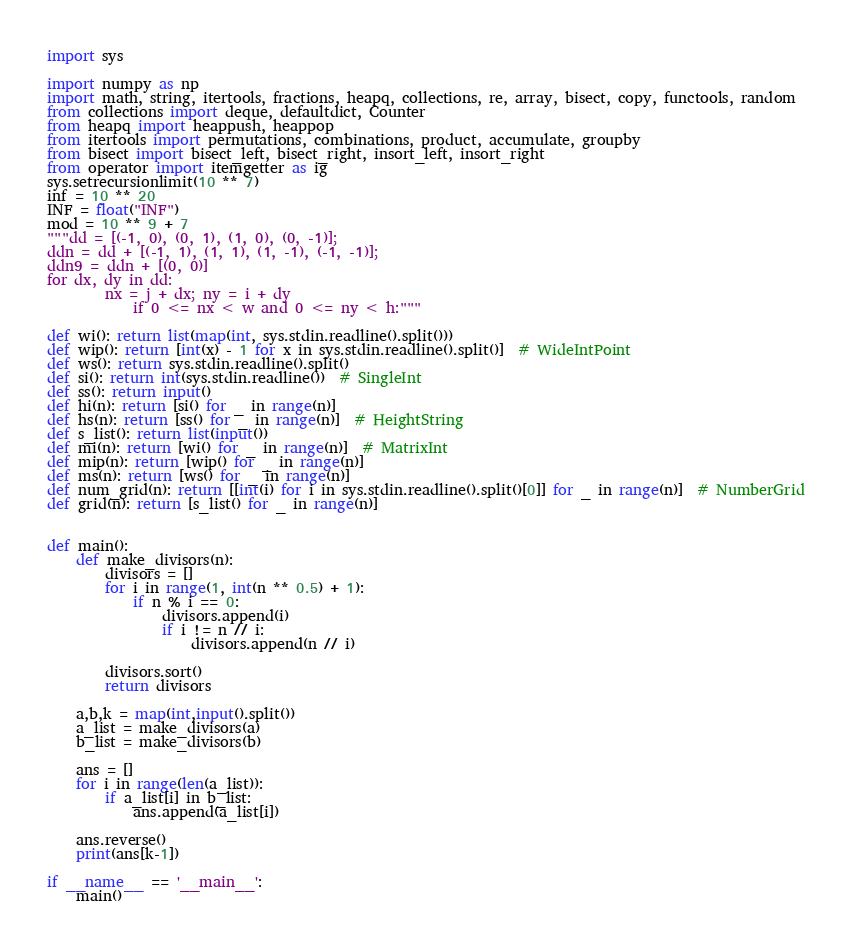<code> <loc_0><loc_0><loc_500><loc_500><_Python_>import sys

import numpy as np
import math, string, itertools, fractions, heapq, collections, re, array, bisect, copy, functools, random
from collections import deque, defaultdict, Counter
from heapq import heappush, heappop
from itertools import permutations, combinations, product, accumulate, groupby
from bisect import bisect_left, bisect_right, insort_left, insort_right
from operator import itemgetter as ig
sys.setrecursionlimit(10 ** 7)
inf = 10 ** 20
INF = float("INF")
mod = 10 ** 9 + 7
"""dd = [(-1, 0), (0, 1), (1, 0), (0, -1)];
ddn = dd + [(-1, 1), (1, 1), (1, -1), (-1, -1)];
ddn9 = ddn + [(0, 0)]
for dx, dy in dd:
        nx = j + dx; ny = i + dy
            if 0 <= nx < w and 0 <= ny < h:"""

def wi(): return list(map(int, sys.stdin.readline().split()))
def wip(): return [int(x) - 1 for x in sys.stdin.readline().split()]  # WideIntPoint
def ws(): return sys.stdin.readline().split()
def si(): return int(sys.stdin.readline())  # SingleInt
def ss(): return input()
def hi(n): return [si() for _ in range(n)]
def hs(n): return [ss() for _ in range(n)]  # HeightString
def s_list(): return list(input())
def mi(n): return [wi() for _ in range(n)]  # MatrixInt
def mip(n): return [wip() for _ in range(n)]
def ms(n): return [ws() for _ in range(n)]
def num_grid(n): return [[int(i) for i in sys.stdin.readline().split()[0]] for _ in range(n)]  # NumberGrid
def grid(n): return [s_list() for _ in range(n)]


def main():
    def make_divisors(n):
        divisors = []
        for i in range(1, int(n ** 0.5) + 1):
            if n % i == 0:
                divisors.append(i)
                if i != n // i:
                    divisors.append(n // i)

        divisors.sort()
        return divisors

    a,b,k = map(int,input().split())
    a_list = make_divisors(a)
    b_list = make_divisors(b)

    ans = []
    for i in range(len(a_list)):
        if a_list[i] in b_list:
            ans.append(a_list[i])

    ans.reverse()
    print(ans[k-1])

if __name__ == '__main__':
    main()</code> 